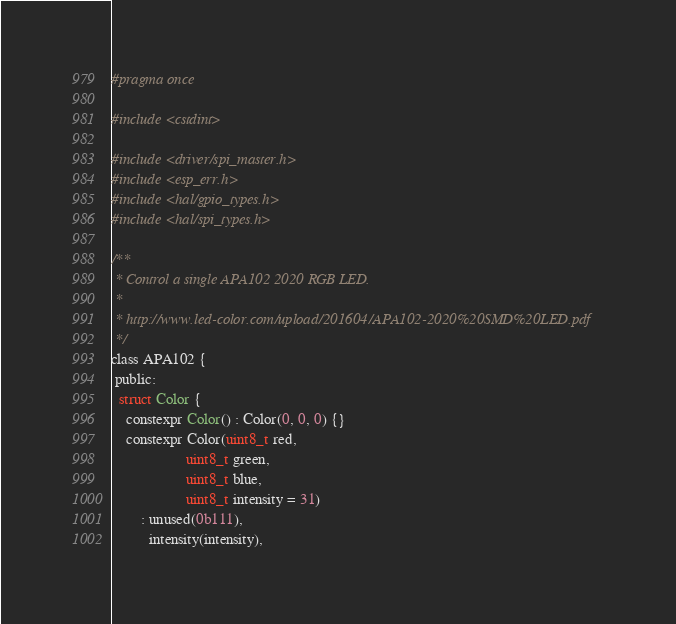<code> <loc_0><loc_0><loc_500><loc_500><_C_>#pragma once

#include <cstdint>

#include <driver/spi_master.h>
#include <esp_err.h>
#include <hal/gpio_types.h>
#include <hal/spi_types.h>

/**
 * Control a single APA102 2020 RGB LED.
 *
 * http://www.led-color.com/upload/201604/APA102-2020%20SMD%20LED.pdf
 */
class APA102 {
 public:
  struct Color {
    constexpr Color() : Color(0, 0, 0) {}
    constexpr Color(uint8_t red,
                    uint8_t green,
                    uint8_t blue,
                    uint8_t intensity = 31)
        : unused(0b111),
          intensity(intensity),</code> 